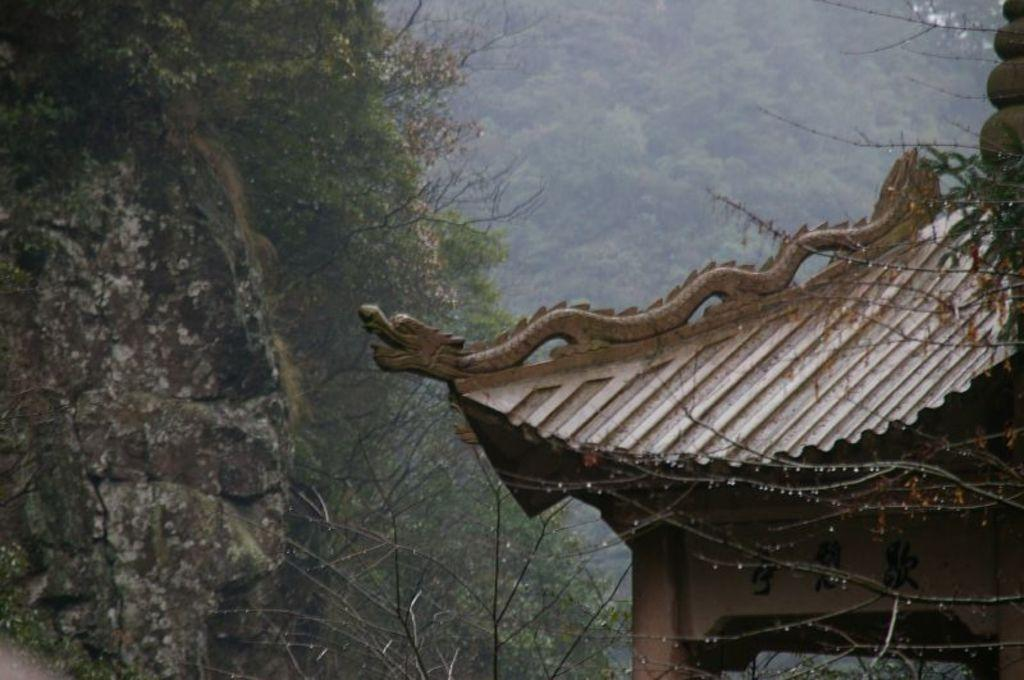What type of structure is present in the image, located towards the right? There is a building in the image, located towards the right. What natural element is present in the image, located towards the left? There is a rock in the image, located towards the left. What type of vegetation can be seen in the image? There are trees in the image. What type of shop can be seen in the cemetery in the image? There is no shop or cemetery present in the image; it features a building and a rock with trees. 